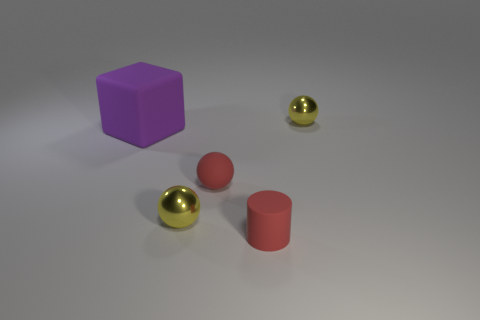How do the shadows cast by the objects inform us about the light source? The shadows in the image are relatively soft and extend to the lower right, which implies the light source is situated to the upper left of the scene. The shadows help in understanding the spatial relationship between the objects and the direction of the lighting. 